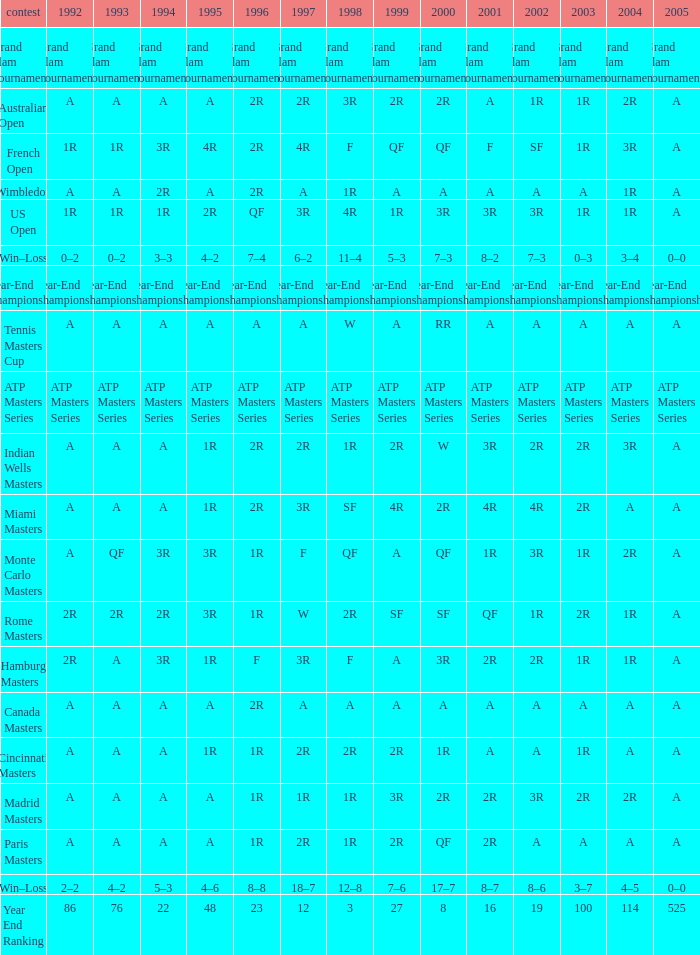What is 1992, when 1999 is "Year-End Championship"? Year-End Championship. 